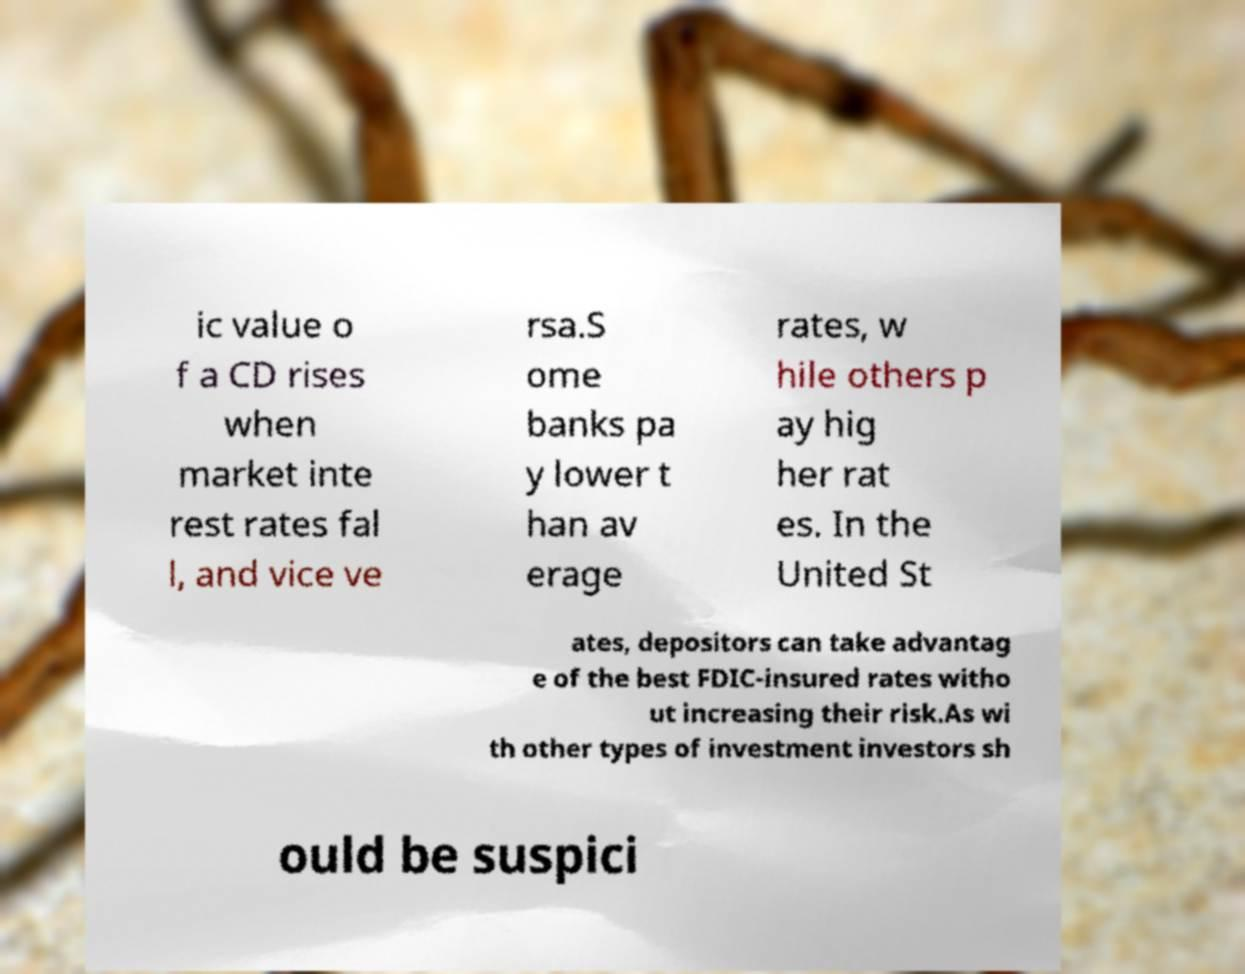There's text embedded in this image that I need extracted. Can you transcribe it verbatim? ic value o f a CD rises when market inte rest rates fal l, and vice ve rsa.S ome banks pa y lower t han av erage rates, w hile others p ay hig her rat es. In the United St ates, depositors can take advantag e of the best FDIC-insured rates witho ut increasing their risk.As wi th other types of investment investors sh ould be suspici 